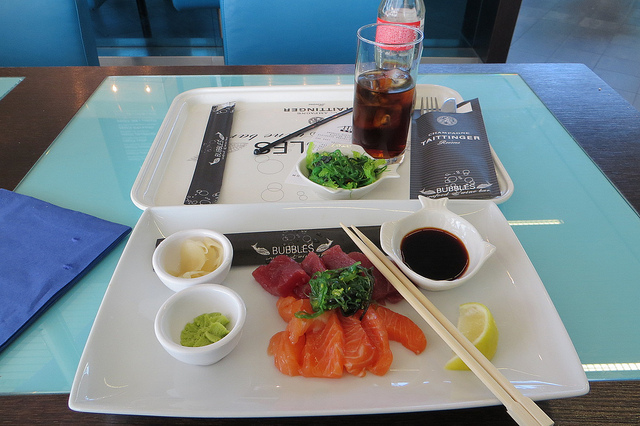Read and extract the text from this image. 897 BUBBLES BUBBLES AITTINOER 